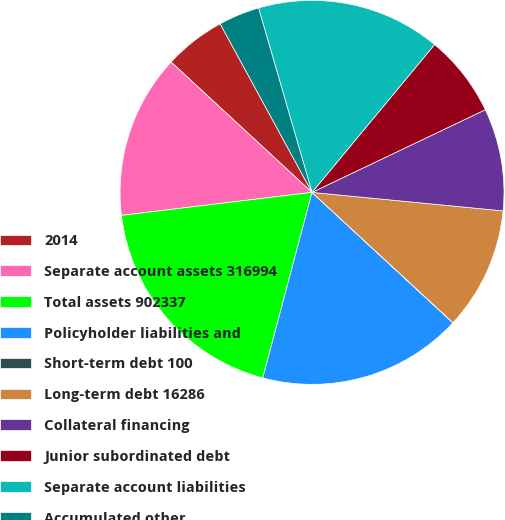Convert chart. <chart><loc_0><loc_0><loc_500><loc_500><pie_chart><fcel>2014<fcel>Separate account assets 316994<fcel>Total assets 902337<fcel>Policyholder liabilities and<fcel>Short-term debt 100<fcel>Long-term debt 16286<fcel>Collateral financing<fcel>Junior subordinated debt<fcel>Separate account liabilities<fcel>Accumulated other<nl><fcel>5.18%<fcel>13.79%<fcel>18.96%<fcel>17.24%<fcel>0.01%<fcel>10.34%<fcel>8.62%<fcel>6.9%<fcel>15.51%<fcel>3.45%<nl></chart> 